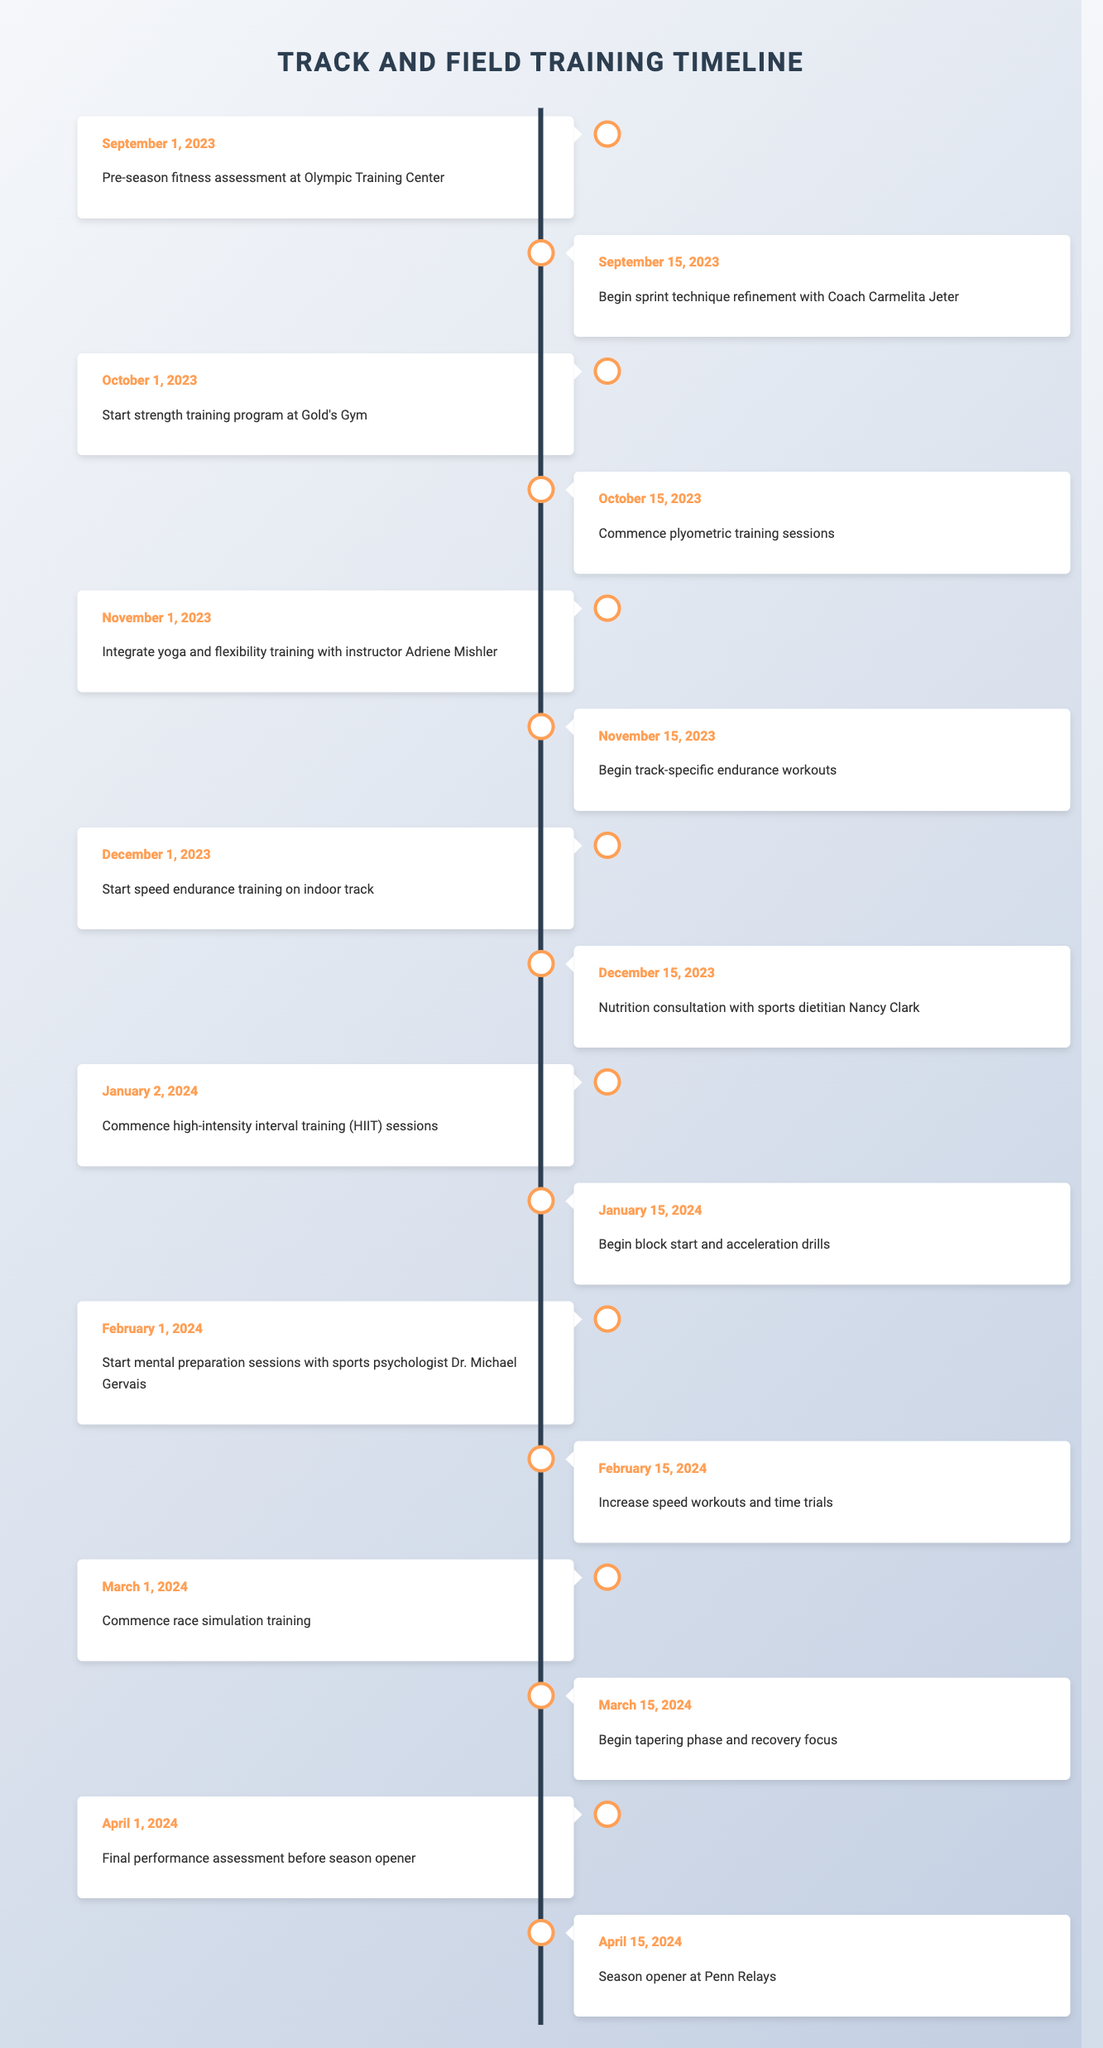What is the first training event scheduled for the upcoming track and field season? The first training event listed in the table is on September 1, 2023, which is the pre-season fitness assessment at the Olympic Training Center.
Answer: Pre-season fitness assessment at Olympic Training Center When does the plyometric training sessions start? The tutorial shows that plyometric training sessions commence on October 15, 2023.
Answer: October 15, 2023 Is there a nutrition consultation with a sports dietitian included in the schedule? Yes, there is a nutrition consultation scheduled with sports dietitian Nancy Clark on December 15, 2023.
Answer: Yes What is the last training event before the season opener? The last training event before the season opener is the final performance assessment, scheduled for April 1, 2024.
Answer: Final performance assessment before season opener How many weeks are there between the start of strength training and the season opener? Strength training starts on October 1, 2023, and the season opener is on April 15, 2024. Counting the weeks, there are 6 months, which is approximately 26 weeks, between these two events.
Answer: 26 weeks What type of training begins on February 1, 2024? On February 1, 2024, mental preparation sessions with sports psychologist Dr. Michael Gervais start.
Answer: Mental preparation sessions with sports psychologist Dr. Michael Gervais Is the tapering phase scheduled to start before the final performance assessment? Yes, the tapering phase begins on March 15, 2024, which is before the final performance assessment on April 1, 2024.
Answer: Yes What are the two events that take place in January 2024? The two events scheduled in January 2024 are: 1. Commence high-intensity interval training (HIIT) sessions on January 2 and 2. Begin block start and acceleration drills on January 15.
Answer: High-intensity interval training (HIIT) and block start/acceleration drills What is the total number of events listed in the timetable? By counting each entry in the timeline data, there are a total of 15 events scheduled from September 2023 to April 2024.
Answer: 15 events 